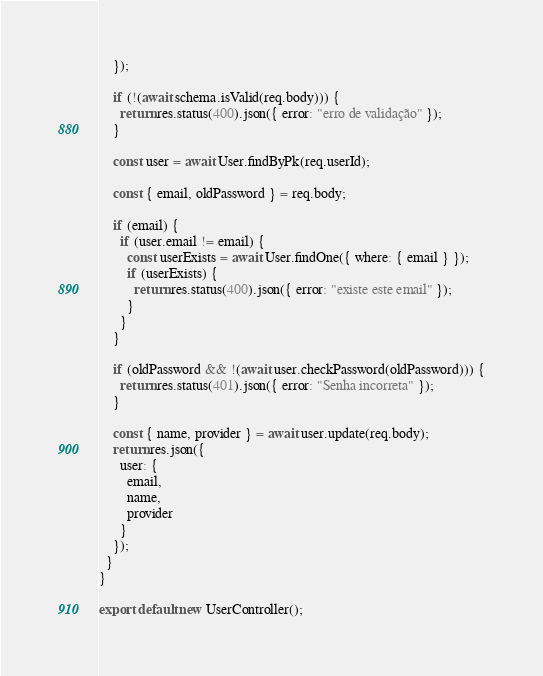Convert code to text. <code><loc_0><loc_0><loc_500><loc_500><_JavaScript_>    });

    if (!(await schema.isValid(req.body))) {
      return res.status(400).json({ error: "erro de validação" });
    }

    const user = await User.findByPk(req.userId);

    const { email, oldPassword } = req.body;

    if (email) {
      if (user.email != email) {
        const userExists = await User.findOne({ where: { email } });
        if (userExists) {
          return res.status(400).json({ error: "existe este email" });
        }
      }
    }

    if (oldPassword && !(await user.checkPassword(oldPassword))) {
      return res.status(401).json({ error: "Senha incorreta" });
    }

    const { name, provider } = await user.update(req.body);
    return res.json({
      user: {
        email,
        name,
        provider
      }
    });
  }
}

export default new UserController();
</code> 